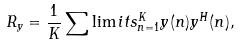<formula> <loc_0><loc_0><loc_500><loc_500>R _ { y } = \frac { 1 } { K } \sum \lim i t s _ { n = 1 } ^ { K } y ( n ) y ^ { H } ( n ) ,</formula> 